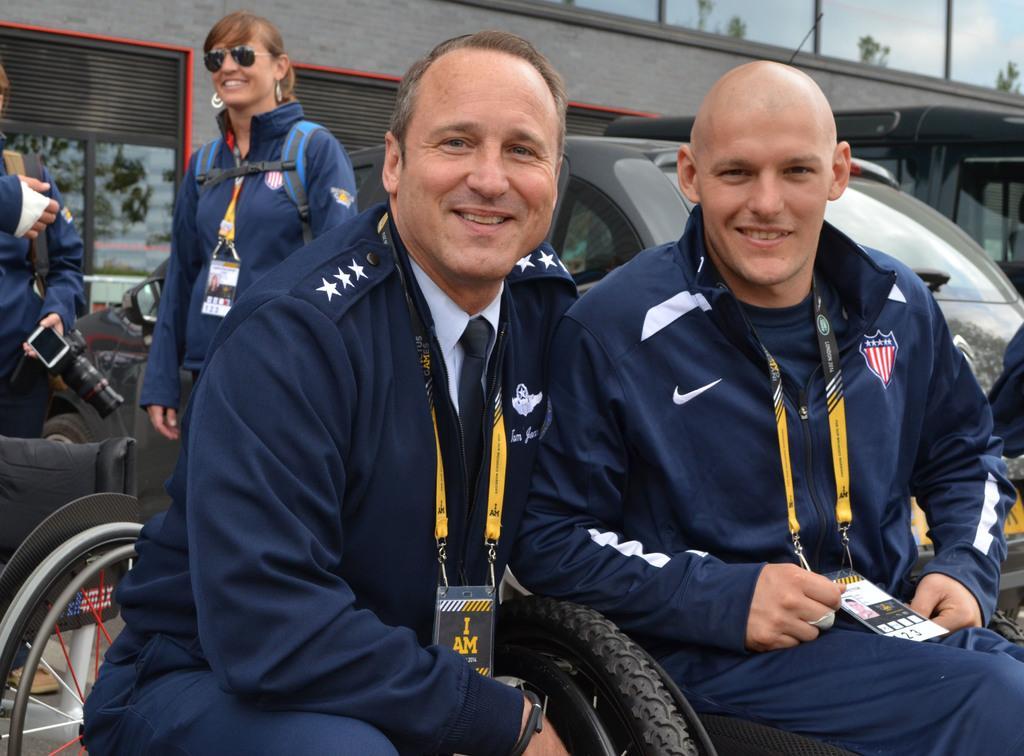Could you give a brief overview of what you see in this image? In this image I can see group of people. In front I can see two persons sitting and wearing blue color dress, background I can see a vehicle in black color, few plants in green color, a building in gray color and I can also see few glass windows. 